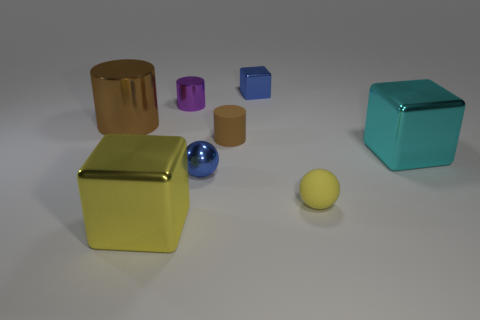Subtract all blue blocks. How many brown cylinders are left? 2 Add 1 small purple metal things. How many objects exist? 9 Subtract all balls. How many objects are left? 6 Subtract all tiny purple cubes. Subtract all big cyan shiny objects. How many objects are left? 7 Add 1 blue metal blocks. How many blue metal blocks are left? 2 Add 2 small yellow rubber balls. How many small yellow rubber balls exist? 3 Subtract 0 red cylinders. How many objects are left? 8 